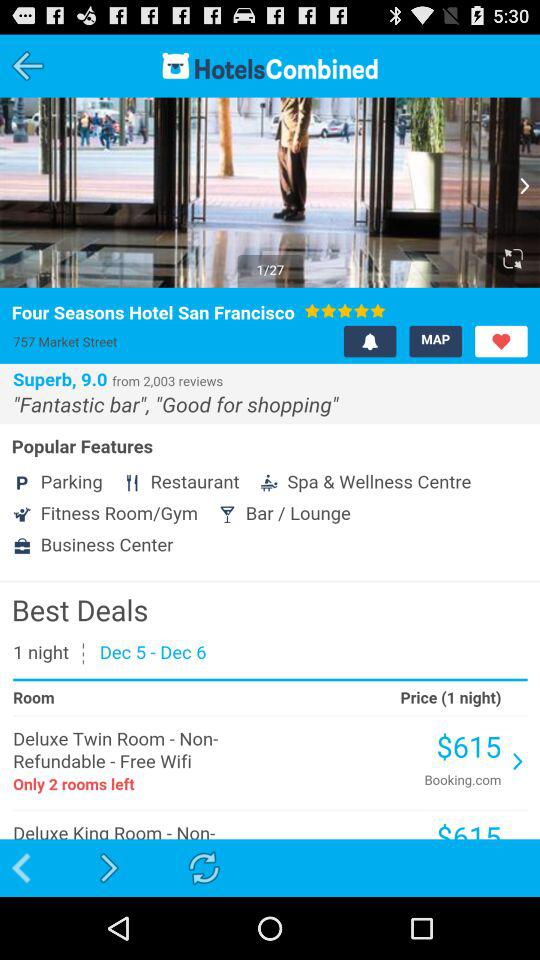How many reviews are there? There are 2,003 reviews. 